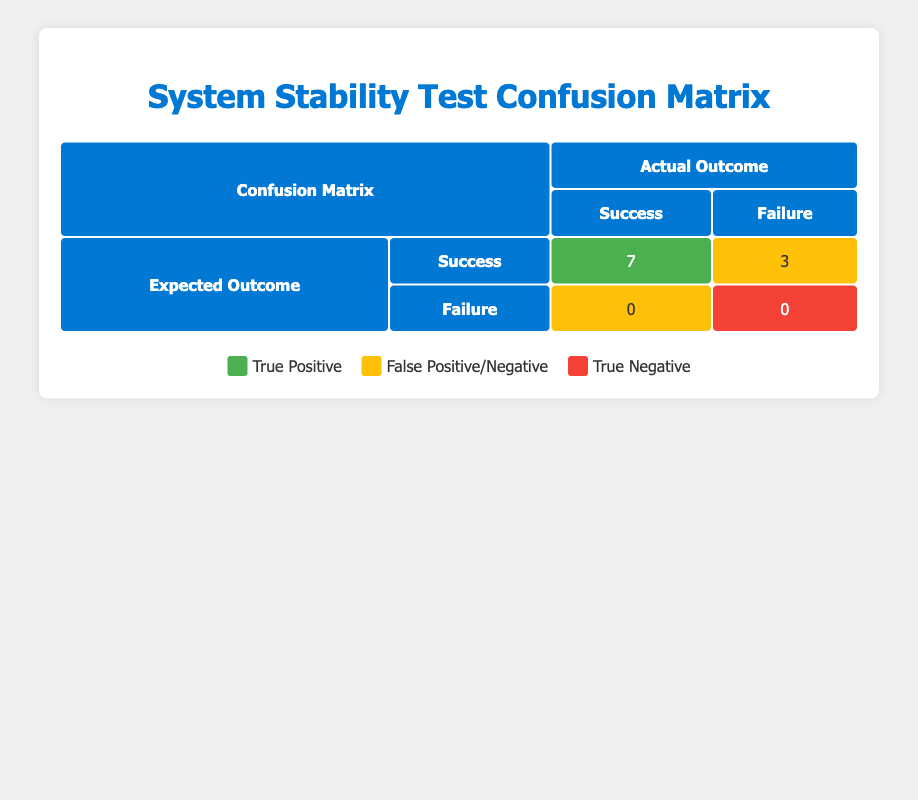What is the total number of test cases? There are 10 test cases listed in the table representing the system stability tests conducted.
Answer: 10 How many test cases had an expected outcome of success but failed? From the table, we see that there are 3 instances where the expected outcome was success, but the actual outcome was failure. These cases are "Run Windows Update", "Perform System Restore", and "Execute Command Prompt."
Answer: 3 What is the number of true positives in the confusion matrix? The true positives represent the number of test cases that were expected to succeed and actually succeeded. The table indicates there are 7 true positives.
Answer: 7 Is it true that there were no false negatives? A false negative occurs when a test case is expected to fail but actually succeeds; according to the table, the value for false negatives is 0. Thus, this statement is true.
Answer: True How many test cases had an actual outcome of failure? The table shows that out of the 10 test cases, there were 3 that had an actual outcome of failure, specifically in the cases of "Run Windows Update", "Perform System Restore", and "Execute Command Prompt."
Answer: 3 What percentage of test cases resulted in a true positive? To calculate this, we divide the number of true positives (7) by the total number of test cases (10) and then multiply by 100 to get the percentage. Therefore, (7/10) * 100 = 70%.
Answer: 70% What is the relationship between expected outcomes and actual outcomes in this testing scenario? The relationship is that the actual outcomes are evaluated against the expected outcomes to determine success or failure. The confusion matrix provides a visual representation of this relationship with counts of true positives, false positives, true negatives, and false negatives.
Answer: They are compared for evaluation of test results How many test cases ended with a successful outcome? The successful outcomes are those where the actual outcome matches the expected outcome of success. Referencing the table, 7 test cases ended with successful outcomes.
Answer: 7 What is the proportion of false positives to total test cases? There are 3 false positives out of a total of 10 test cases. The proportion is calculated by dividing the number of false positives by the total number of test cases, which is 3/10 = 0.3 or 30%.
Answer: 30% 